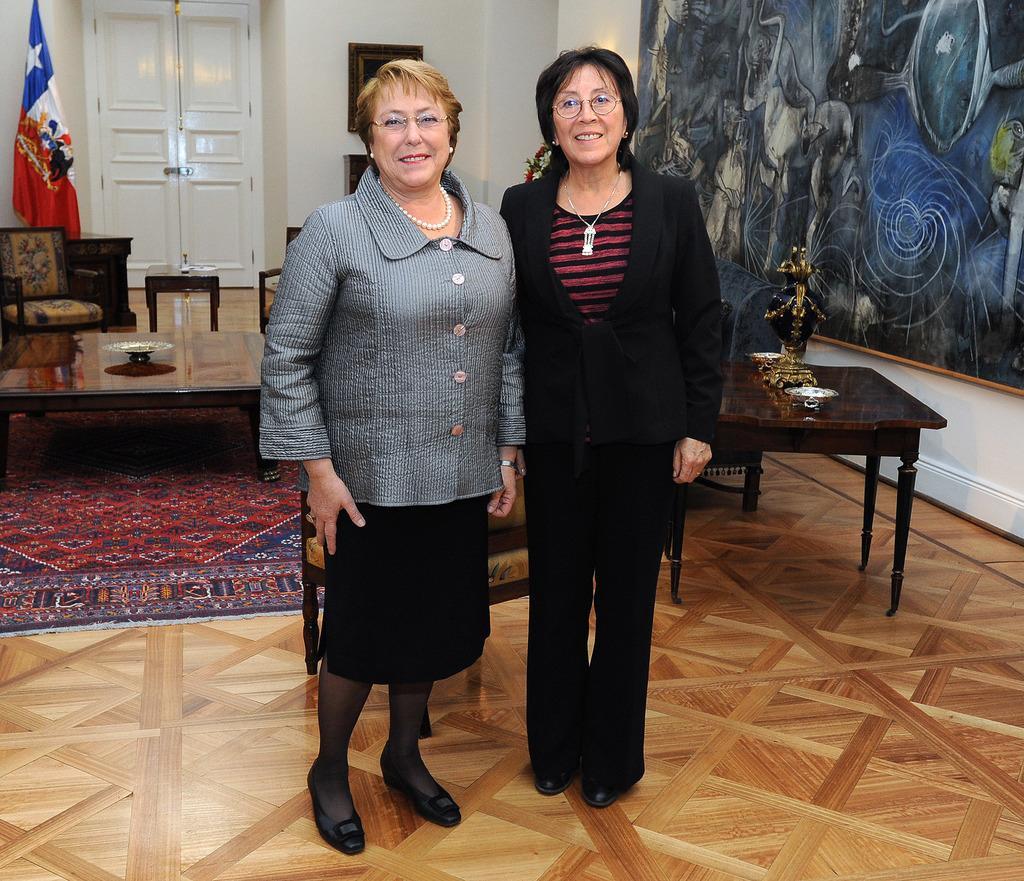Please provide a concise description of this image. In this picture we can find two women standing on a floor. In the background we can find a table, some painting on the wall, white doors, photo frames, flag, chair, stools, and floor mat. 